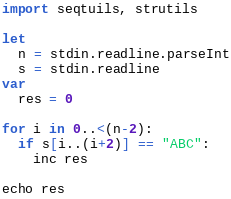Convert code to text. <code><loc_0><loc_0><loc_500><loc_500><_Nim_>import seqtuils, strutils

let
  n = stdin.readline.parseInt
  s = stdin.readline
var
  res = 0

for i in 0..<(n-2):
  if s[i..(i+2)] == "ABC":
    inc res

echo res
</code> 